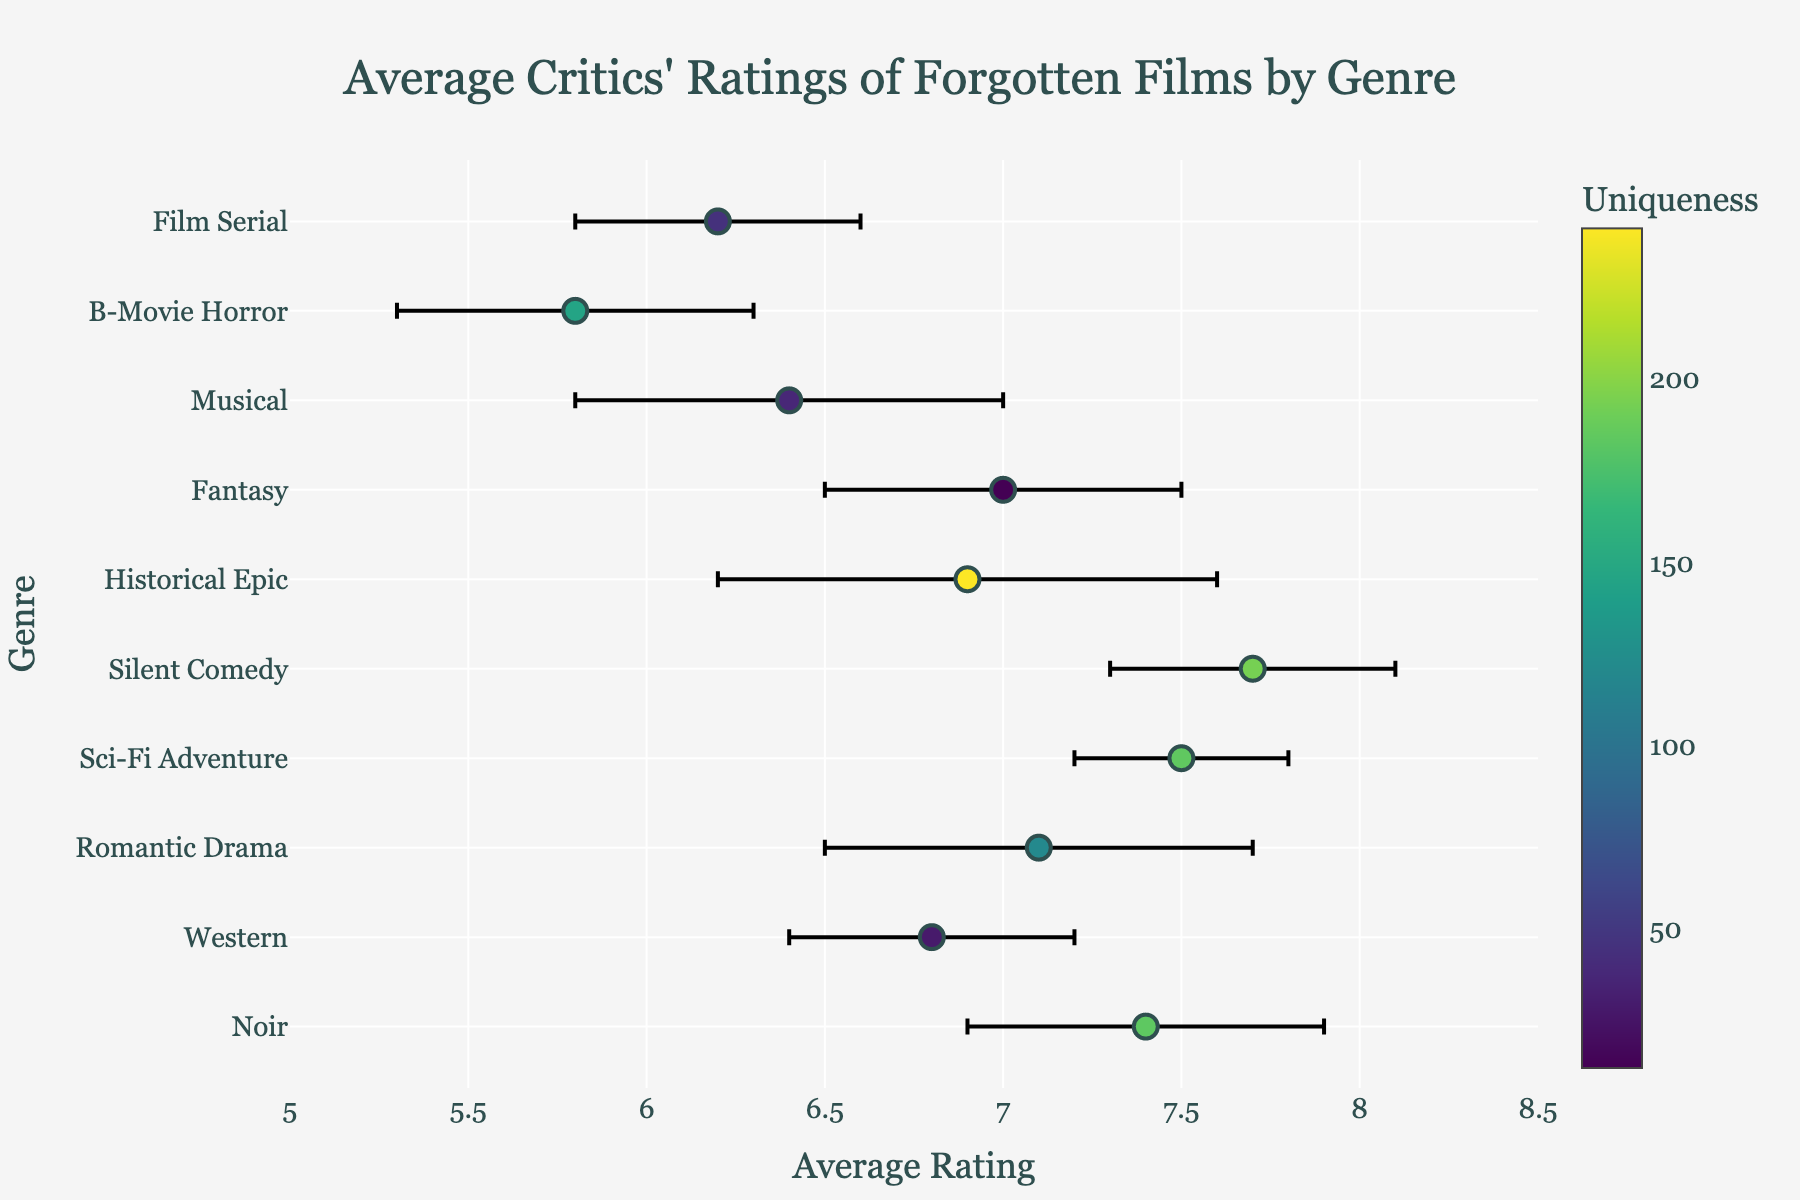What is the title of the figure? The title is displayed at the top of the figure. It reads "Average Critics' Ratings of Forgotten Films by Genre".
Answer: Average Critics' Ratings of Forgotten Films by Genre What genre has the highest average rating? The dot that is farthest to the right represents the highest average rating. This is for the "Silent Comedy" genre.
Answer: Silent Comedy Which two genres have the same margin of error? By looking at the length of the error bars, we observe that "Noir" and "Fantasy" both have error bars of equal length.
Answer: Noir and Fantasy What is the average rating for "Western" films? Locate the dot corresponding to the "Western" genre and read the x-axis value. The average rating is 6.8.
Answer: 6.8 What genre has the lowest average rating, and what is that rating? The dot farthest to the left corresponds to the lowest average rating which belongs to the "B-Movie Horror" genre. The rating is 5.8.
Answer: B-Movie Horror, 5.8 What is the difference in the average ratings between "Sci-Fi Adventure" and "Historical Epic"? The average rating for "Sci-Fi Adventure" is 7.5 and for "Historical Epic" is 6.9. The difference is obtained by subtracting the two values: 7.5 - 6.9 = 0.6
Answer: 0.6 What's the median average rating of all genres listed? First, list all average ratings in ascending order: 5.8, 6.2, 6.4, 6.8, 6.9, 7.0, 7.1, 7.4, 7.5, 7.7. The median is the middle value when an odd number of values are listed. With 10 values, calculate the median by averaging the 5th and 6th values: (6.9 + 7.0) / 2 = 6.95.
Answer: 6.95 Which genre has the largest margin of error? The genre with the longest error bar represents the largest margin of error. In this case, it is "Historical Epic," with a margin of error of 0.7.
Answer: Historical Epic Is the average rating for "Musical" higher than that of "Film Serial"? Check their dot positions. The average rating for "Musical" is 6.4, and for "Film Serial" it is 6.2. Since 6.4 > 6.2, the rating for "Musical" is higher.
Answer: Yes 